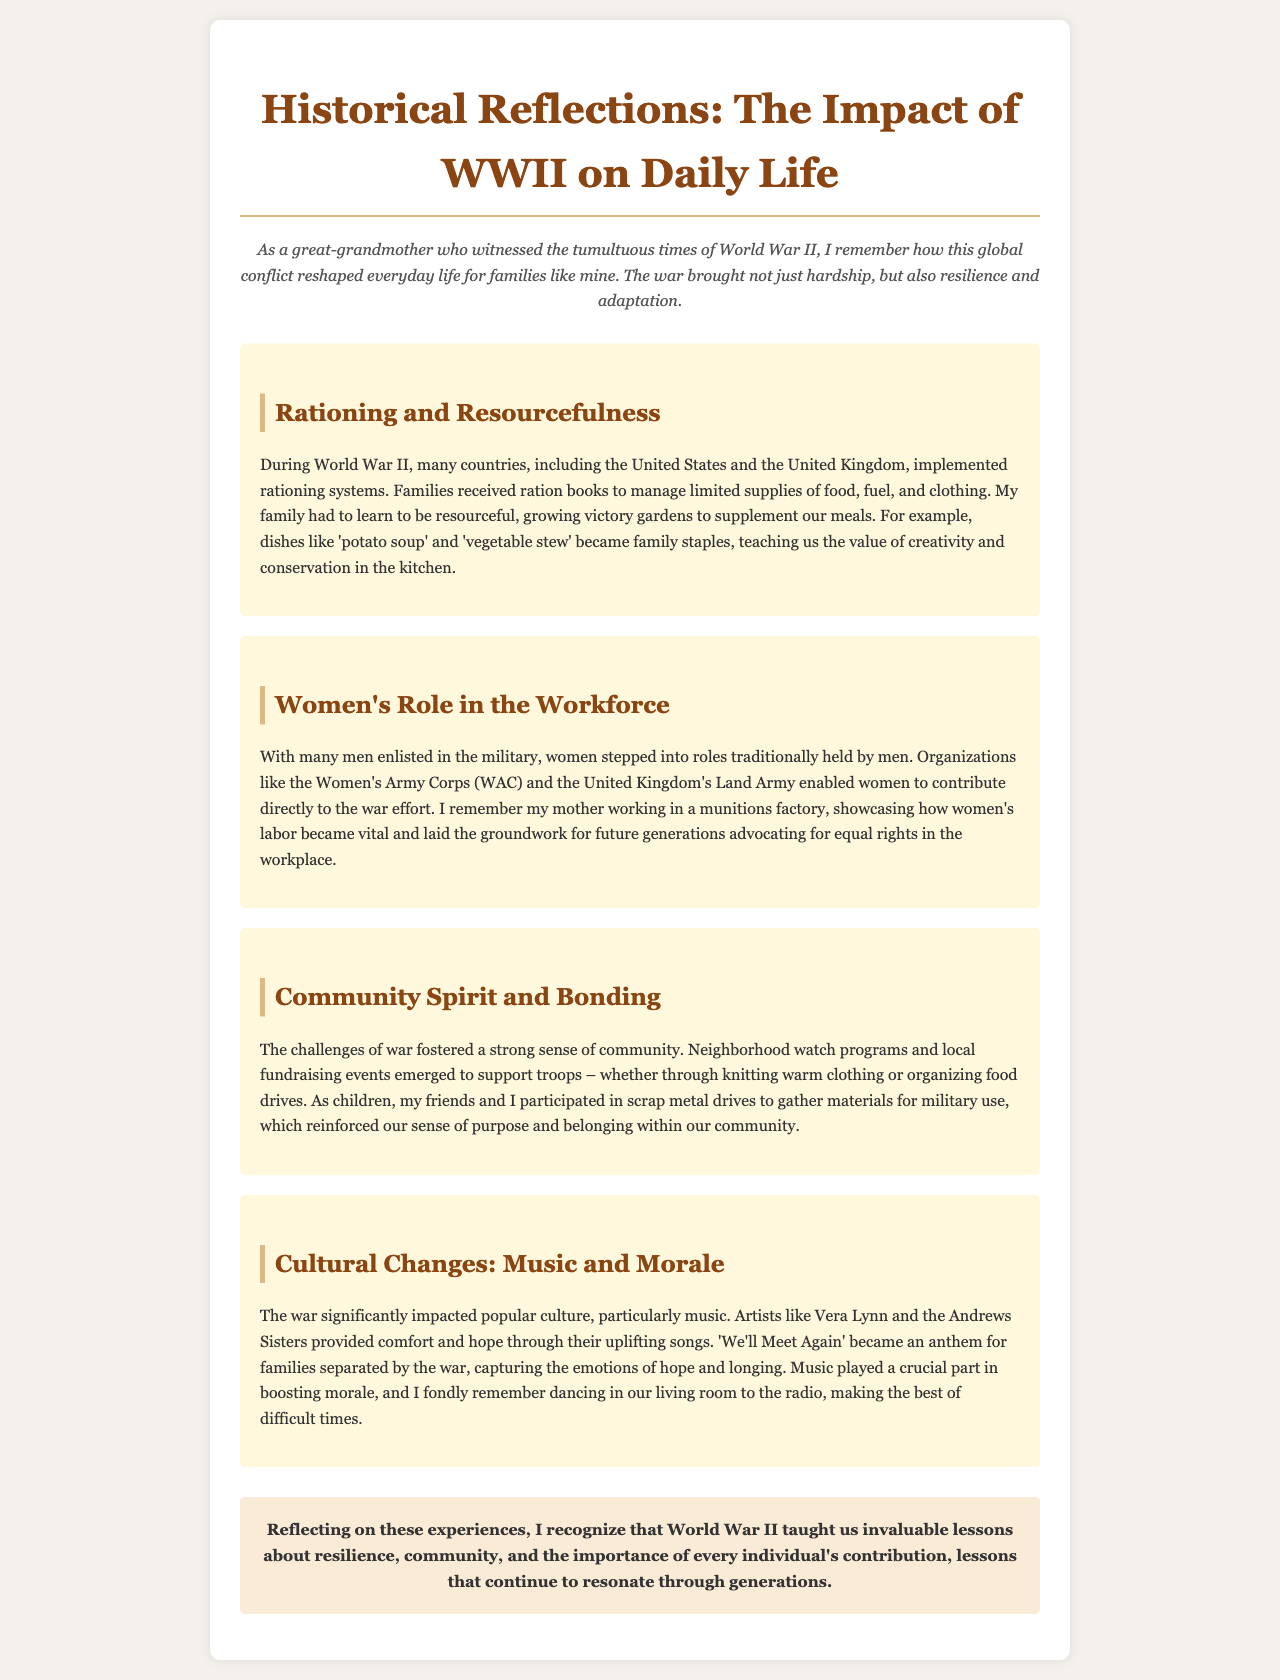what type of gardens were grown during WWII? The document mentions that families grew victory gardens to supplement their meals.
Answer: victory gardens which organization allowed women to contribute directly to the war effort? The Women's Army Corps (WAC) is highlighted as one organization enabling women's contributions.
Answer: Women's Army Corps (WAC) what song became an anthem for families separated by the war? The document states that "We'll Meet Again" captured the emotions of hope and longing during the war.
Answer: We'll Meet Again what was a common meal during the rationing period? The document describes potato soup and vegetable stew as family staples during WWII.
Answer: potato soup how did children contribute to their communities during the war? The document explains that children participated in scrap metal drives to support the military efforts.
Answer: scrap metal drives what was one way communities supported troops during WWII? The document provides examples of local fundraising events and knitting warm clothing as community support.
Answer: knitting warm clothing which two artists were mentioned for providing comfort through music? The document mentions Vera Lynn and the Andrews Sisters as artists uplifting spirits during the war.
Answer: Vera Lynn and the Andrews Sisters what is the tone of the concluding reflection in the document? The conclusion reflects on resilience, community, and invaluable lessons learned during the war.
Answer: resilience and community how did women’s labor during WWII impact future generations? The document states women's labor laid the groundwork for future generations advocating for equal rights in the workplace.
Answer: equal rights in the workplace 